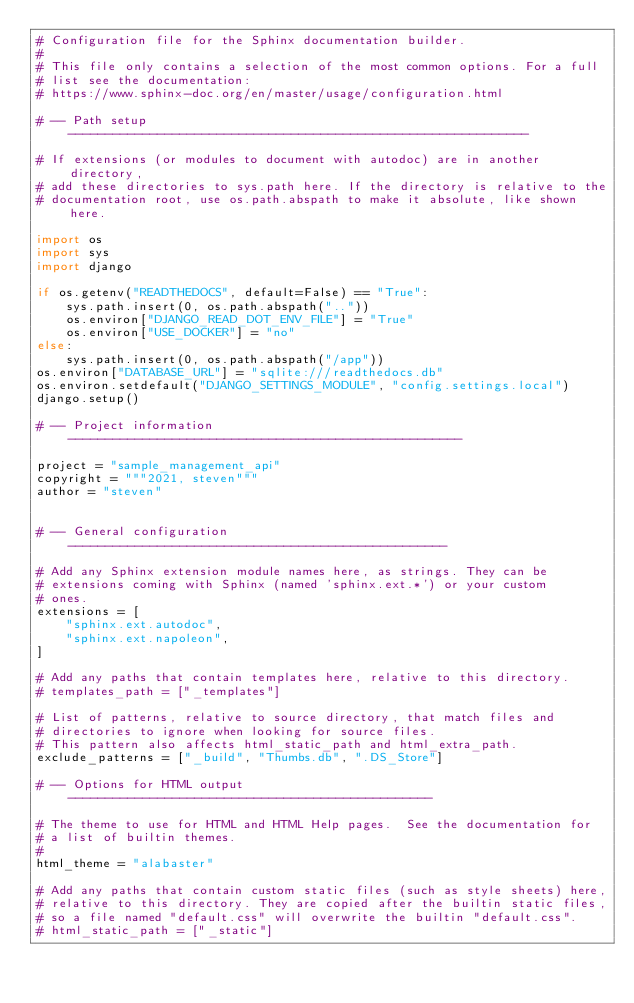<code> <loc_0><loc_0><loc_500><loc_500><_Python_># Configuration file for the Sphinx documentation builder.
#
# This file only contains a selection of the most common options. For a full
# list see the documentation:
# https://www.sphinx-doc.org/en/master/usage/configuration.html

# -- Path setup --------------------------------------------------------------

# If extensions (or modules to document with autodoc) are in another directory,
# add these directories to sys.path here. If the directory is relative to the
# documentation root, use os.path.abspath to make it absolute, like shown here.

import os
import sys
import django

if os.getenv("READTHEDOCS", default=False) == "True":
    sys.path.insert(0, os.path.abspath(".."))
    os.environ["DJANGO_READ_DOT_ENV_FILE"] = "True"
    os.environ["USE_DOCKER"] = "no"
else:
    sys.path.insert(0, os.path.abspath("/app"))
os.environ["DATABASE_URL"] = "sqlite:///readthedocs.db"
os.environ.setdefault("DJANGO_SETTINGS_MODULE", "config.settings.local")
django.setup()

# -- Project information -----------------------------------------------------

project = "sample_management_api"
copyright = """2021, steven"""
author = "steven"


# -- General configuration ---------------------------------------------------

# Add any Sphinx extension module names here, as strings. They can be
# extensions coming with Sphinx (named 'sphinx.ext.*') or your custom
# ones.
extensions = [
    "sphinx.ext.autodoc",
    "sphinx.ext.napoleon",
]

# Add any paths that contain templates here, relative to this directory.
# templates_path = ["_templates"]

# List of patterns, relative to source directory, that match files and
# directories to ignore when looking for source files.
# This pattern also affects html_static_path and html_extra_path.
exclude_patterns = ["_build", "Thumbs.db", ".DS_Store"]

# -- Options for HTML output -------------------------------------------------

# The theme to use for HTML and HTML Help pages.  See the documentation for
# a list of builtin themes.
#
html_theme = "alabaster"

# Add any paths that contain custom static files (such as style sheets) here,
# relative to this directory. They are copied after the builtin static files,
# so a file named "default.css" will overwrite the builtin "default.css".
# html_static_path = ["_static"]
</code> 